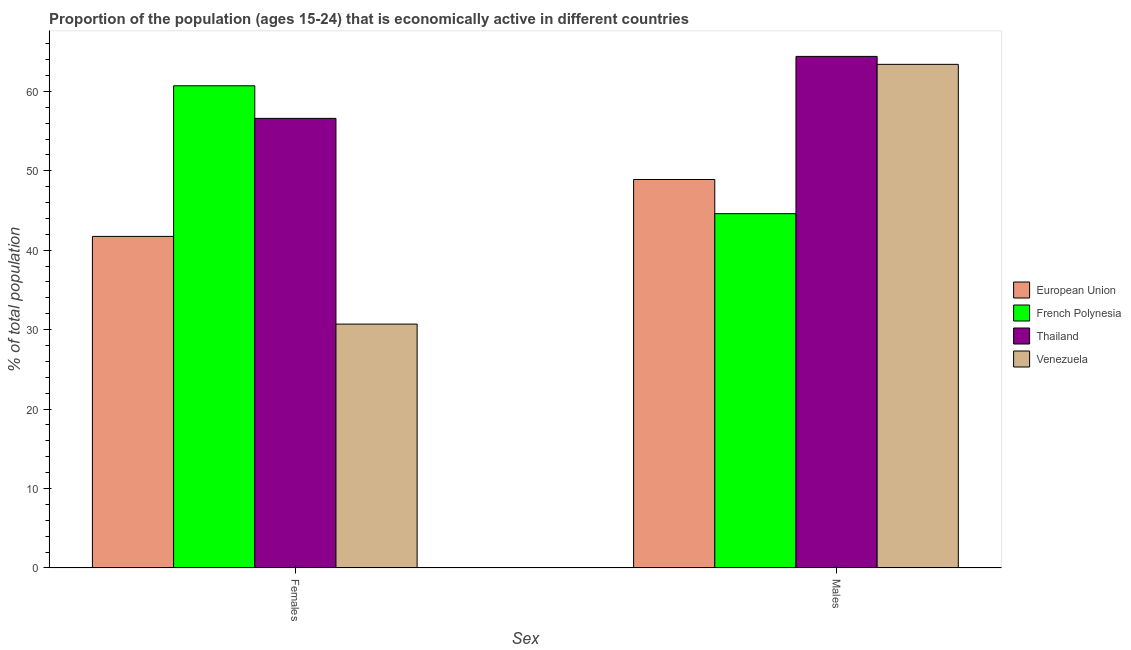How many different coloured bars are there?
Your answer should be compact. 4. Are the number of bars per tick equal to the number of legend labels?
Provide a short and direct response. Yes. What is the label of the 2nd group of bars from the left?
Keep it short and to the point. Males. What is the percentage of economically active female population in French Polynesia?
Your answer should be very brief. 60.7. Across all countries, what is the maximum percentage of economically active male population?
Your answer should be compact. 64.4. Across all countries, what is the minimum percentage of economically active male population?
Provide a succinct answer. 44.6. In which country was the percentage of economically active male population maximum?
Make the answer very short. Thailand. In which country was the percentage of economically active female population minimum?
Your answer should be compact. Venezuela. What is the total percentage of economically active female population in the graph?
Your answer should be compact. 189.74. What is the difference between the percentage of economically active female population in French Polynesia and that in Venezuela?
Your answer should be very brief. 30. What is the difference between the percentage of economically active female population in Venezuela and the percentage of economically active male population in European Union?
Give a very brief answer. -18.2. What is the average percentage of economically active female population per country?
Your response must be concise. 47.44. What is the difference between the percentage of economically active male population and percentage of economically active female population in French Polynesia?
Offer a terse response. -16.1. What is the ratio of the percentage of economically active male population in Thailand to that in Venezuela?
Your answer should be very brief. 1.02. Is the percentage of economically active male population in French Polynesia less than that in Venezuela?
Your answer should be compact. Yes. In how many countries, is the percentage of economically active female population greater than the average percentage of economically active female population taken over all countries?
Give a very brief answer. 2. What does the 3rd bar from the left in Females represents?
Offer a very short reply. Thailand. What does the 3rd bar from the right in Females represents?
Give a very brief answer. French Polynesia. Are all the bars in the graph horizontal?
Your answer should be very brief. No. What is the difference between two consecutive major ticks on the Y-axis?
Keep it short and to the point. 10. Does the graph contain any zero values?
Make the answer very short. No. Does the graph contain grids?
Provide a short and direct response. No. How many legend labels are there?
Provide a succinct answer. 4. What is the title of the graph?
Your answer should be compact. Proportion of the population (ages 15-24) that is economically active in different countries. Does "Nicaragua" appear as one of the legend labels in the graph?
Your answer should be compact. No. What is the label or title of the X-axis?
Provide a short and direct response. Sex. What is the label or title of the Y-axis?
Your response must be concise. % of total population. What is the % of total population of European Union in Females?
Ensure brevity in your answer.  41.74. What is the % of total population in French Polynesia in Females?
Your response must be concise. 60.7. What is the % of total population in Thailand in Females?
Your response must be concise. 56.6. What is the % of total population of Venezuela in Females?
Provide a succinct answer. 30.7. What is the % of total population in European Union in Males?
Give a very brief answer. 48.9. What is the % of total population of French Polynesia in Males?
Provide a succinct answer. 44.6. What is the % of total population of Thailand in Males?
Keep it short and to the point. 64.4. What is the % of total population in Venezuela in Males?
Give a very brief answer. 63.4. Across all Sex, what is the maximum % of total population of European Union?
Your answer should be very brief. 48.9. Across all Sex, what is the maximum % of total population in French Polynesia?
Offer a very short reply. 60.7. Across all Sex, what is the maximum % of total population in Thailand?
Keep it short and to the point. 64.4. Across all Sex, what is the maximum % of total population of Venezuela?
Your answer should be very brief. 63.4. Across all Sex, what is the minimum % of total population in European Union?
Ensure brevity in your answer.  41.74. Across all Sex, what is the minimum % of total population in French Polynesia?
Keep it short and to the point. 44.6. Across all Sex, what is the minimum % of total population in Thailand?
Provide a succinct answer. 56.6. Across all Sex, what is the minimum % of total population in Venezuela?
Your response must be concise. 30.7. What is the total % of total population of European Union in the graph?
Ensure brevity in your answer.  90.64. What is the total % of total population in French Polynesia in the graph?
Your response must be concise. 105.3. What is the total % of total population in Thailand in the graph?
Provide a succinct answer. 121. What is the total % of total population of Venezuela in the graph?
Your response must be concise. 94.1. What is the difference between the % of total population of European Union in Females and that in Males?
Your answer should be compact. -7.16. What is the difference between the % of total population of Thailand in Females and that in Males?
Give a very brief answer. -7.8. What is the difference between the % of total population in Venezuela in Females and that in Males?
Ensure brevity in your answer.  -32.7. What is the difference between the % of total population in European Union in Females and the % of total population in French Polynesia in Males?
Offer a terse response. -2.86. What is the difference between the % of total population in European Union in Females and the % of total population in Thailand in Males?
Make the answer very short. -22.66. What is the difference between the % of total population in European Union in Females and the % of total population in Venezuela in Males?
Your answer should be very brief. -21.66. What is the difference between the % of total population of French Polynesia in Females and the % of total population of Thailand in Males?
Offer a very short reply. -3.7. What is the difference between the % of total population in Thailand in Females and the % of total population in Venezuela in Males?
Keep it short and to the point. -6.8. What is the average % of total population in European Union per Sex?
Your answer should be very brief. 45.32. What is the average % of total population of French Polynesia per Sex?
Make the answer very short. 52.65. What is the average % of total population of Thailand per Sex?
Make the answer very short. 60.5. What is the average % of total population of Venezuela per Sex?
Keep it short and to the point. 47.05. What is the difference between the % of total population of European Union and % of total population of French Polynesia in Females?
Offer a very short reply. -18.96. What is the difference between the % of total population of European Union and % of total population of Thailand in Females?
Your response must be concise. -14.86. What is the difference between the % of total population in European Union and % of total population in Venezuela in Females?
Your answer should be compact. 11.04. What is the difference between the % of total population in French Polynesia and % of total population in Venezuela in Females?
Keep it short and to the point. 30. What is the difference between the % of total population of Thailand and % of total population of Venezuela in Females?
Keep it short and to the point. 25.9. What is the difference between the % of total population of European Union and % of total population of French Polynesia in Males?
Make the answer very short. 4.3. What is the difference between the % of total population in European Union and % of total population in Thailand in Males?
Give a very brief answer. -15.5. What is the difference between the % of total population in European Union and % of total population in Venezuela in Males?
Make the answer very short. -14.5. What is the difference between the % of total population of French Polynesia and % of total population of Thailand in Males?
Give a very brief answer. -19.8. What is the difference between the % of total population of French Polynesia and % of total population of Venezuela in Males?
Your response must be concise. -18.8. What is the difference between the % of total population of Thailand and % of total population of Venezuela in Males?
Offer a terse response. 1. What is the ratio of the % of total population in European Union in Females to that in Males?
Make the answer very short. 0.85. What is the ratio of the % of total population in French Polynesia in Females to that in Males?
Provide a short and direct response. 1.36. What is the ratio of the % of total population of Thailand in Females to that in Males?
Offer a very short reply. 0.88. What is the ratio of the % of total population of Venezuela in Females to that in Males?
Your answer should be compact. 0.48. What is the difference between the highest and the second highest % of total population of European Union?
Ensure brevity in your answer.  7.16. What is the difference between the highest and the second highest % of total population in French Polynesia?
Your answer should be compact. 16.1. What is the difference between the highest and the second highest % of total population of Venezuela?
Your answer should be compact. 32.7. What is the difference between the highest and the lowest % of total population of European Union?
Provide a succinct answer. 7.16. What is the difference between the highest and the lowest % of total population of French Polynesia?
Your answer should be very brief. 16.1. What is the difference between the highest and the lowest % of total population of Thailand?
Your answer should be compact. 7.8. What is the difference between the highest and the lowest % of total population of Venezuela?
Provide a short and direct response. 32.7. 